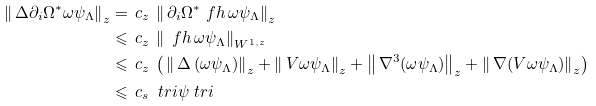Convert formula to latex. <formula><loc_0><loc_0><loc_500><loc_500>\left \| \, \Delta \partial _ { i } \Omega ^ { * } \omega \psi _ { \Lambda } \right \| _ { z } & = \, c _ { z } \, \left \| \, \partial _ { i } \Omega ^ { * } \ f h \, \omega \psi _ { \Lambda } \right \| _ { z } \\ & \leqslant \, c _ { z } \, \left \| \, \ f h \, \omega \psi _ { \Lambda } \right \| _ { W ^ { 1 , z } } \\ & \leqslant \, c _ { z } \, \left ( \, \left \| \, \Delta \, ( \omega \psi _ { \Lambda } ) \right \| _ { z } + \left \| \, V \omega \psi _ { \Lambda } \right \| _ { z } + \left \| \, \nabla ^ { 3 } ( \omega \psi _ { \Lambda } ) \right \| _ { z } + \left \| \, \nabla ( V \omega \psi _ { \Lambda } ) \right \| _ { z } \right ) \\ & \leqslant \, c _ { s } \, \ t r i \psi \ t r i</formula> 